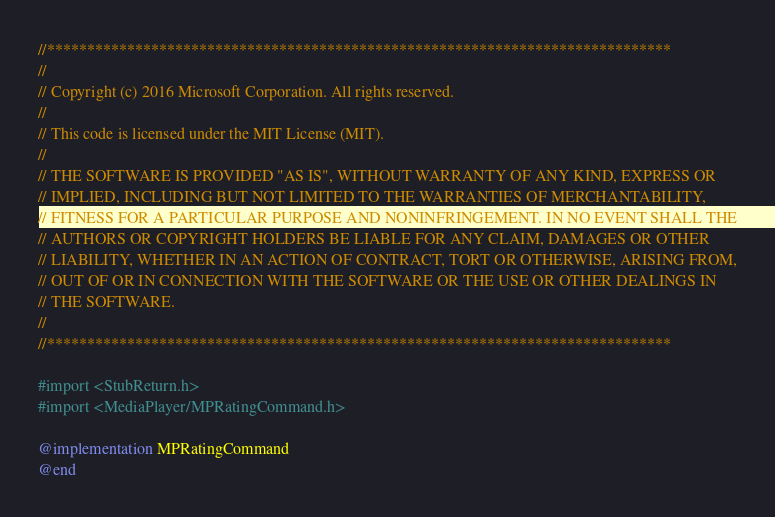<code> <loc_0><loc_0><loc_500><loc_500><_ObjectiveC_>//******************************************************************************
//
// Copyright (c) 2016 Microsoft Corporation. All rights reserved.
//
// This code is licensed under the MIT License (MIT).
//
// THE SOFTWARE IS PROVIDED "AS IS", WITHOUT WARRANTY OF ANY KIND, EXPRESS OR
// IMPLIED, INCLUDING BUT NOT LIMITED TO THE WARRANTIES OF MERCHANTABILITY,
// FITNESS FOR A PARTICULAR PURPOSE AND NONINFRINGEMENT. IN NO EVENT SHALL THE
// AUTHORS OR COPYRIGHT HOLDERS BE LIABLE FOR ANY CLAIM, DAMAGES OR OTHER
// LIABILITY, WHETHER IN AN ACTION OF CONTRACT, TORT OR OTHERWISE, ARISING FROM,
// OUT OF OR IN CONNECTION WITH THE SOFTWARE OR THE USE OR OTHER DEALINGS IN
// THE SOFTWARE.
//
//******************************************************************************

#import <StubReturn.h>
#import <MediaPlayer/MPRatingCommand.h>

@implementation MPRatingCommand
@end
</code> 